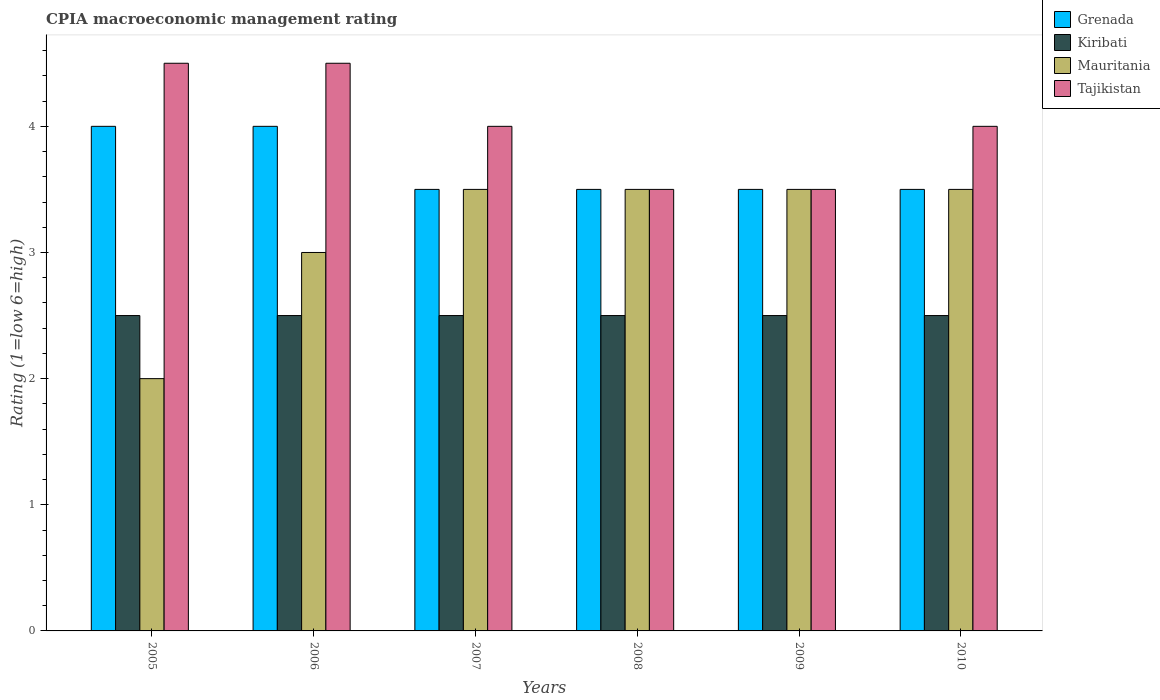Are the number of bars on each tick of the X-axis equal?
Your answer should be very brief. Yes. How many bars are there on the 4th tick from the left?
Make the answer very short. 4. How many bars are there on the 1st tick from the right?
Make the answer very short. 4. In which year was the CPIA rating in Grenada maximum?
Your response must be concise. 2005. In which year was the CPIA rating in Kiribati minimum?
Make the answer very short. 2005. What is the difference between the CPIA rating in Kiribati in 2008 and that in 2010?
Give a very brief answer. 0. What is the average CPIA rating in Grenada per year?
Keep it short and to the point. 3.67. In the year 2010, what is the difference between the CPIA rating in Mauritania and CPIA rating in Tajikistan?
Your answer should be compact. -0.5. In how many years, is the CPIA rating in Mauritania greater than 0.6000000000000001?
Provide a succinct answer. 6. What is the ratio of the CPIA rating in Grenada in 2006 to that in 2007?
Keep it short and to the point. 1.14. Is the CPIA rating in Mauritania in 2008 less than that in 2009?
Your answer should be compact. No. In how many years, is the CPIA rating in Grenada greater than the average CPIA rating in Grenada taken over all years?
Your response must be concise. 2. Is it the case that in every year, the sum of the CPIA rating in Kiribati and CPIA rating in Mauritania is greater than the sum of CPIA rating in Tajikistan and CPIA rating in Grenada?
Offer a very short reply. No. What does the 4th bar from the left in 2010 represents?
Ensure brevity in your answer.  Tajikistan. What does the 4th bar from the right in 2007 represents?
Ensure brevity in your answer.  Grenada. Is it the case that in every year, the sum of the CPIA rating in Tajikistan and CPIA rating in Grenada is greater than the CPIA rating in Kiribati?
Keep it short and to the point. Yes. How many years are there in the graph?
Your answer should be compact. 6. Does the graph contain any zero values?
Your answer should be very brief. No. Where does the legend appear in the graph?
Provide a succinct answer. Top right. How many legend labels are there?
Your answer should be very brief. 4. How are the legend labels stacked?
Your answer should be compact. Vertical. What is the title of the graph?
Give a very brief answer. CPIA macroeconomic management rating. Does "Djibouti" appear as one of the legend labels in the graph?
Keep it short and to the point. No. What is the label or title of the Y-axis?
Keep it short and to the point. Rating (1=low 6=high). What is the Rating (1=low 6=high) in Grenada in 2005?
Your answer should be very brief. 4. What is the Rating (1=low 6=high) in Mauritania in 2005?
Offer a terse response. 2. What is the Rating (1=low 6=high) of Tajikistan in 2005?
Make the answer very short. 4.5. What is the Rating (1=low 6=high) in Mauritania in 2006?
Your response must be concise. 3. What is the Rating (1=low 6=high) in Mauritania in 2007?
Give a very brief answer. 3.5. What is the Rating (1=low 6=high) in Tajikistan in 2007?
Your answer should be compact. 4. What is the Rating (1=low 6=high) in Grenada in 2008?
Provide a short and direct response. 3.5. What is the Rating (1=low 6=high) in Kiribati in 2008?
Your answer should be very brief. 2.5. What is the Rating (1=low 6=high) of Tajikistan in 2008?
Make the answer very short. 3.5. What is the Rating (1=low 6=high) in Kiribati in 2009?
Offer a terse response. 2.5. What is the Rating (1=low 6=high) of Grenada in 2010?
Make the answer very short. 3.5. What is the Rating (1=low 6=high) of Kiribati in 2010?
Your response must be concise. 2.5. What is the Rating (1=low 6=high) in Mauritania in 2010?
Ensure brevity in your answer.  3.5. What is the Rating (1=low 6=high) in Tajikistan in 2010?
Ensure brevity in your answer.  4. Across all years, what is the maximum Rating (1=low 6=high) in Grenada?
Provide a succinct answer. 4. Across all years, what is the maximum Rating (1=low 6=high) of Mauritania?
Your response must be concise. 3.5. Across all years, what is the minimum Rating (1=low 6=high) in Kiribati?
Keep it short and to the point. 2.5. Across all years, what is the minimum Rating (1=low 6=high) of Mauritania?
Offer a very short reply. 2. Across all years, what is the minimum Rating (1=low 6=high) of Tajikistan?
Give a very brief answer. 3.5. What is the total Rating (1=low 6=high) of Grenada in the graph?
Provide a succinct answer. 22. What is the total Rating (1=low 6=high) in Mauritania in the graph?
Your answer should be very brief. 19. What is the total Rating (1=low 6=high) in Tajikistan in the graph?
Provide a succinct answer. 24. What is the difference between the Rating (1=low 6=high) in Grenada in 2005 and that in 2006?
Offer a terse response. 0. What is the difference between the Rating (1=low 6=high) in Mauritania in 2005 and that in 2006?
Provide a short and direct response. -1. What is the difference between the Rating (1=low 6=high) of Grenada in 2005 and that in 2007?
Provide a short and direct response. 0.5. What is the difference between the Rating (1=low 6=high) of Kiribati in 2005 and that in 2007?
Offer a terse response. 0. What is the difference between the Rating (1=low 6=high) of Grenada in 2005 and that in 2008?
Give a very brief answer. 0.5. What is the difference between the Rating (1=low 6=high) in Kiribati in 2005 and that in 2008?
Offer a terse response. 0. What is the difference between the Rating (1=low 6=high) in Mauritania in 2005 and that in 2008?
Provide a succinct answer. -1.5. What is the difference between the Rating (1=low 6=high) of Grenada in 2005 and that in 2009?
Give a very brief answer. 0.5. What is the difference between the Rating (1=low 6=high) of Kiribati in 2005 and that in 2009?
Ensure brevity in your answer.  0. What is the difference between the Rating (1=low 6=high) in Grenada in 2005 and that in 2010?
Offer a terse response. 0.5. What is the difference between the Rating (1=low 6=high) in Tajikistan in 2005 and that in 2010?
Ensure brevity in your answer.  0.5. What is the difference between the Rating (1=low 6=high) of Mauritania in 2006 and that in 2007?
Provide a short and direct response. -0.5. What is the difference between the Rating (1=low 6=high) in Grenada in 2006 and that in 2008?
Ensure brevity in your answer.  0.5. What is the difference between the Rating (1=low 6=high) in Kiribati in 2006 and that in 2008?
Offer a very short reply. 0. What is the difference between the Rating (1=low 6=high) in Mauritania in 2006 and that in 2008?
Give a very brief answer. -0.5. What is the difference between the Rating (1=low 6=high) in Tajikistan in 2006 and that in 2008?
Ensure brevity in your answer.  1. What is the difference between the Rating (1=low 6=high) in Kiribati in 2006 and that in 2009?
Offer a very short reply. 0. What is the difference between the Rating (1=low 6=high) in Grenada in 2006 and that in 2010?
Your answer should be compact. 0.5. What is the difference between the Rating (1=low 6=high) of Kiribati in 2006 and that in 2010?
Keep it short and to the point. 0. What is the difference between the Rating (1=low 6=high) in Mauritania in 2006 and that in 2010?
Make the answer very short. -0.5. What is the difference between the Rating (1=low 6=high) of Tajikistan in 2006 and that in 2010?
Keep it short and to the point. 0.5. What is the difference between the Rating (1=low 6=high) of Grenada in 2007 and that in 2008?
Keep it short and to the point. 0. What is the difference between the Rating (1=low 6=high) of Tajikistan in 2007 and that in 2009?
Your answer should be very brief. 0.5. What is the difference between the Rating (1=low 6=high) of Grenada in 2007 and that in 2010?
Offer a terse response. 0. What is the difference between the Rating (1=low 6=high) of Tajikistan in 2007 and that in 2010?
Keep it short and to the point. 0. What is the difference between the Rating (1=low 6=high) in Kiribati in 2008 and that in 2009?
Keep it short and to the point. 0. What is the difference between the Rating (1=low 6=high) of Mauritania in 2008 and that in 2009?
Your answer should be very brief. 0. What is the difference between the Rating (1=low 6=high) of Tajikistan in 2008 and that in 2009?
Keep it short and to the point. 0. What is the difference between the Rating (1=low 6=high) of Grenada in 2008 and that in 2010?
Your answer should be compact. 0. What is the difference between the Rating (1=low 6=high) of Mauritania in 2008 and that in 2010?
Provide a short and direct response. 0. What is the difference between the Rating (1=low 6=high) in Kiribati in 2009 and that in 2010?
Your answer should be compact. 0. What is the difference between the Rating (1=low 6=high) of Grenada in 2005 and the Rating (1=low 6=high) of Kiribati in 2006?
Provide a short and direct response. 1.5. What is the difference between the Rating (1=low 6=high) of Grenada in 2005 and the Rating (1=low 6=high) of Mauritania in 2006?
Make the answer very short. 1. What is the difference between the Rating (1=low 6=high) of Mauritania in 2005 and the Rating (1=low 6=high) of Tajikistan in 2006?
Offer a very short reply. -2.5. What is the difference between the Rating (1=low 6=high) in Kiribati in 2005 and the Rating (1=low 6=high) in Tajikistan in 2007?
Ensure brevity in your answer.  -1.5. What is the difference between the Rating (1=low 6=high) in Mauritania in 2005 and the Rating (1=low 6=high) in Tajikistan in 2007?
Provide a succinct answer. -2. What is the difference between the Rating (1=low 6=high) of Grenada in 2005 and the Rating (1=low 6=high) of Tajikistan in 2008?
Give a very brief answer. 0.5. What is the difference between the Rating (1=low 6=high) in Kiribati in 2005 and the Rating (1=low 6=high) in Mauritania in 2008?
Offer a very short reply. -1. What is the difference between the Rating (1=low 6=high) of Mauritania in 2005 and the Rating (1=low 6=high) of Tajikistan in 2008?
Keep it short and to the point. -1.5. What is the difference between the Rating (1=low 6=high) of Grenada in 2005 and the Rating (1=low 6=high) of Mauritania in 2009?
Offer a terse response. 0.5. What is the difference between the Rating (1=low 6=high) of Kiribati in 2005 and the Rating (1=low 6=high) of Mauritania in 2009?
Provide a succinct answer. -1. What is the difference between the Rating (1=low 6=high) in Kiribati in 2005 and the Rating (1=low 6=high) in Tajikistan in 2009?
Your answer should be compact. -1. What is the difference between the Rating (1=low 6=high) of Kiribati in 2005 and the Rating (1=low 6=high) of Mauritania in 2010?
Offer a terse response. -1. What is the difference between the Rating (1=low 6=high) in Kiribati in 2005 and the Rating (1=low 6=high) in Tajikistan in 2010?
Provide a short and direct response. -1.5. What is the difference between the Rating (1=low 6=high) of Mauritania in 2005 and the Rating (1=low 6=high) of Tajikistan in 2010?
Provide a succinct answer. -2. What is the difference between the Rating (1=low 6=high) of Grenada in 2006 and the Rating (1=low 6=high) of Kiribati in 2007?
Provide a succinct answer. 1.5. What is the difference between the Rating (1=low 6=high) of Grenada in 2006 and the Rating (1=low 6=high) of Mauritania in 2007?
Your response must be concise. 0.5. What is the difference between the Rating (1=low 6=high) of Grenada in 2006 and the Rating (1=low 6=high) of Tajikistan in 2007?
Make the answer very short. 0. What is the difference between the Rating (1=low 6=high) in Kiribati in 2006 and the Rating (1=low 6=high) in Mauritania in 2007?
Your answer should be compact. -1. What is the difference between the Rating (1=low 6=high) of Kiribati in 2006 and the Rating (1=low 6=high) of Tajikistan in 2007?
Make the answer very short. -1.5. What is the difference between the Rating (1=low 6=high) of Mauritania in 2006 and the Rating (1=low 6=high) of Tajikistan in 2007?
Make the answer very short. -1. What is the difference between the Rating (1=low 6=high) in Grenada in 2006 and the Rating (1=low 6=high) in Kiribati in 2008?
Your response must be concise. 1.5. What is the difference between the Rating (1=low 6=high) of Grenada in 2006 and the Rating (1=low 6=high) of Tajikistan in 2008?
Offer a very short reply. 0.5. What is the difference between the Rating (1=low 6=high) of Kiribati in 2006 and the Rating (1=low 6=high) of Mauritania in 2008?
Your answer should be compact. -1. What is the difference between the Rating (1=low 6=high) of Grenada in 2006 and the Rating (1=low 6=high) of Mauritania in 2009?
Your answer should be compact. 0.5. What is the difference between the Rating (1=low 6=high) in Grenada in 2006 and the Rating (1=low 6=high) in Tajikistan in 2009?
Your answer should be very brief. 0.5. What is the difference between the Rating (1=low 6=high) of Kiribati in 2006 and the Rating (1=low 6=high) of Mauritania in 2009?
Your response must be concise. -1. What is the difference between the Rating (1=low 6=high) in Grenada in 2006 and the Rating (1=low 6=high) in Kiribati in 2010?
Ensure brevity in your answer.  1.5. What is the difference between the Rating (1=low 6=high) of Grenada in 2006 and the Rating (1=low 6=high) of Tajikistan in 2010?
Your answer should be very brief. 0. What is the difference between the Rating (1=low 6=high) in Kiribati in 2006 and the Rating (1=low 6=high) in Mauritania in 2010?
Your response must be concise. -1. What is the difference between the Rating (1=low 6=high) of Kiribati in 2006 and the Rating (1=low 6=high) of Tajikistan in 2010?
Provide a short and direct response. -1.5. What is the difference between the Rating (1=low 6=high) of Mauritania in 2006 and the Rating (1=low 6=high) of Tajikistan in 2010?
Give a very brief answer. -1. What is the difference between the Rating (1=low 6=high) in Grenada in 2007 and the Rating (1=low 6=high) in Kiribati in 2008?
Make the answer very short. 1. What is the difference between the Rating (1=low 6=high) in Grenada in 2007 and the Rating (1=low 6=high) in Tajikistan in 2008?
Provide a succinct answer. 0. What is the difference between the Rating (1=low 6=high) in Kiribati in 2007 and the Rating (1=low 6=high) in Mauritania in 2008?
Provide a short and direct response. -1. What is the difference between the Rating (1=low 6=high) in Kiribati in 2007 and the Rating (1=low 6=high) in Tajikistan in 2008?
Make the answer very short. -1. What is the difference between the Rating (1=low 6=high) of Mauritania in 2007 and the Rating (1=low 6=high) of Tajikistan in 2008?
Make the answer very short. 0. What is the difference between the Rating (1=low 6=high) of Grenada in 2007 and the Rating (1=low 6=high) of Kiribati in 2009?
Give a very brief answer. 1. What is the difference between the Rating (1=low 6=high) in Kiribati in 2007 and the Rating (1=low 6=high) in Tajikistan in 2009?
Offer a very short reply. -1. What is the difference between the Rating (1=low 6=high) in Mauritania in 2007 and the Rating (1=low 6=high) in Tajikistan in 2009?
Provide a succinct answer. 0. What is the difference between the Rating (1=low 6=high) of Kiribati in 2007 and the Rating (1=low 6=high) of Mauritania in 2010?
Give a very brief answer. -1. What is the difference between the Rating (1=low 6=high) of Kiribati in 2007 and the Rating (1=low 6=high) of Tajikistan in 2010?
Offer a very short reply. -1.5. What is the difference between the Rating (1=low 6=high) in Grenada in 2008 and the Rating (1=low 6=high) in Kiribati in 2009?
Provide a succinct answer. 1. What is the difference between the Rating (1=low 6=high) in Grenada in 2008 and the Rating (1=low 6=high) in Mauritania in 2009?
Your response must be concise. 0. What is the difference between the Rating (1=low 6=high) in Kiribati in 2008 and the Rating (1=low 6=high) in Mauritania in 2009?
Provide a short and direct response. -1. What is the difference between the Rating (1=low 6=high) of Grenada in 2008 and the Rating (1=low 6=high) of Kiribati in 2010?
Your answer should be compact. 1. What is the difference between the Rating (1=low 6=high) of Grenada in 2008 and the Rating (1=low 6=high) of Tajikistan in 2010?
Make the answer very short. -0.5. What is the difference between the Rating (1=low 6=high) in Kiribati in 2008 and the Rating (1=low 6=high) in Tajikistan in 2010?
Your answer should be very brief. -1.5. What is the difference between the Rating (1=low 6=high) of Mauritania in 2008 and the Rating (1=low 6=high) of Tajikistan in 2010?
Your response must be concise. -0.5. What is the difference between the Rating (1=low 6=high) of Grenada in 2009 and the Rating (1=low 6=high) of Kiribati in 2010?
Your answer should be compact. 1. What is the average Rating (1=low 6=high) of Grenada per year?
Your answer should be compact. 3.67. What is the average Rating (1=low 6=high) in Mauritania per year?
Provide a succinct answer. 3.17. What is the average Rating (1=low 6=high) of Tajikistan per year?
Offer a very short reply. 4. In the year 2005, what is the difference between the Rating (1=low 6=high) of Grenada and Rating (1=low 6=high) of Mauritania?
Give a very brief answer. 2. In the year 2005, what is the difference between the Rating (1=low 6=high) of Kiribati and Rating (1=low 6=high) of Mauritania?
Ensure brevity in your answer.  0.5. In the year 2005, what is the difference between the Rating (1=low 6=high) in Kiribati and Rating (1=low 6=high) in Tajikistan?
Your answer should be very brief. -2. In the year 2005, what is the difference between the Rating (1=low 6=high) in Mauritania and Rating (1=low 6=high) in Tajikistan?
Ensure brevity in your answer.  -2.5. In the year 2007, what is the difference between the Rating (1=low 6=high) in Grenada and Rating (1=low 6=high) in Mauritania?
Offer a terse response. 0. In the year 2007, what is the difference between the Rating (1=low 6=high) in Grenada and Rating (1=low 6=high) in Tajikistan?
Keep it short and to the point. -0.5. In the year 2007, what is the difference between the Rating (1=low 6=high) of Kiribati and Rating (1=low 6=high) of Mauritania?
Make the answer very short. -1. In the year 2007, what is the difference between the Rating (1=low 6=high) in Kiribati and Rating (1=low 6=high) in Tajikistan?
Offer a very short reply. -1.5. In the year 2007, what is the difference between the Rating (1=low 6=high) in Mauritania and Rating (1=low 6=high) in Tajikistan?
Provide a short and direct response. -0.5. In the year 2008, what is the difference between the Rating (1=low 6=high) of Grenada and Rating (1=low 6=high) of Kiribati?
Make the answer very short. 1. In the year 2008, what is the difference between the Rating (1=low 6=high) of Grenada and Rating (1=low 6=high) of Mauritania?
Offer a terse response. 0. In the year 2008, what is the difference between the Rating (1=low 6=high) of Kiribati and Rating (1=low 6=high) of Tajikistan?
Keep it short and to the point. -1. In the year 2009, what is the difference between the Rating (1=low 6=high) in Grenada and Rating (1=low 6=high) in Tajikistan?
Provide a short and direct response. 0. In the year 2009, what is the difference between the Rating (1=low 6=high) in Kiribati and Rating (1=low 6=high) in Mauritania?
Your response must be concise. -1. In the year 2009, what is the difference between the Rating (1=low 6=high) in Kiribati and Rating (1=low 6=high) in Tajikistan?
Give a very brief answer. -1. In the year 2010, what is the difference between the Rating (1=low 6=high) in Grenada and Rating (1=low 6=high) in Kiribati?
Give a very brief answer. 1. In the year 2010, what is the difference between the Rating (1=low 6=high) in Grenada and Rating (1=low 6=high) in Tajikistan?
Keep it short and to the point. -0.5. In the year 2010, what is the difference between the Rating (1=low 6=high) of Kiribati and Rating (1=low 6=high) of Tajikistan?
Your answer should be compact. -1.5. What is the ratio of the Rating (1=low 6=high) in Tajikistan in 2005 to that in 2006?
Offer a very short reply. 1. What is the ratio of the Rating (1=low 6=high) in Tajikistan in 2005 to that in 2007?
Provide a succinct answer. 1.12. What is the ratio of the Rating (1=low 6=high) in Mauritania in 2005 to that in 2008?
Make the answer very short. 0.57. What is the ratio of the Rating (1=low 6=high) of Grenada in 2005 to that in 2009?
Keep it short and to the point. 1.14. What is the ratio of the Rating (1=low 6=high) in Kiribati in 2005 to that in 2009?
Provide a short and direct response. 1. What is the ratio of the Rating (1=low 6=high) of Mauritania in 2005 to that in 2009?
Your response must be concise. 0.57. What is the ratio of the Rating (1=low 6=high) of Tajikistan in 2005 to that in 2009?
Offer a very short reply. 1.29. What is the ratio of the Rating (1=low 6=high) of Mauritania in 2005 to that in 2010?
Provide a short and direct response. 0.57. What is the ratio of the Rating (1=low 6=high) in Kiribati in 2006 to that in 2007?
Your answer should be very brief. 1. What is the ratio of the Rating (1=low 6=high) of Tajikistan in 2006 to that in 2007?
Your response must be concise. 1.12. What is the ratio of the Rating (1=low 6=high) in Grenada in 2006 to that in 2008?
Your answer should be compact. 1.14. What is the ratio of the Rating (1=low 6=high) of Kiribati in 2006 to that in 2008?
Offer a terse response. 1. What is the ratio of the Rating (1=low 6=high) in Mauritania in 2006 to that in 2009?
Give a very brief answer. 0.86. What is the ratio of the Rating (1=low 6=high) of Kiribati in 2006 to that in 2010?
Provide a short and direct response. 1. What is the ratio of the Rating (1=low 6=high) of Mauritania in 2006 to that in 2010?
Give a very brief answer. 0.86. What is the ratio of the Rating (1=low 6=high) in Tajikistan in 2007 to that in 2008?
Keep it short and to the point. 1.14. What is the ratio of the Rating (1=low 6=high) in Grenada in 2007 to that in 2009?
Give a very brief answer. 1. What is the ratio of the Rating (1=low 6=high) of Kiribati in 2007 to that in 2009?
Offer a terse response. 1. What is the ratio of the Rating (1=low 6=high) in Tajikistan in 2007 to that in 2009?
Give a very brief answer. 1.14. What is the ratio of the Rating (1=low 6=high) of Grenada in 2007 to that in 2010?
Give a very brief answer. 1. What is the ratio of the Rating (1=low 6=high) in Kiribati in 2007 to that in 2010?
Keep it short and to the point. 1. What is the ratio of the Rating (1=low 6=high) of Mauritania in 2008 to that in 2009?
Offer a terse response. 1. What is the ratio of the Rating (1=low 6=high) in Tajikistan in 2008 to that in 2009?
Provide a succinct answer. 1. What is the ratio of the Rating (1=low 6=high) in Grenada in 2008 to that in 2010?
Make the answer very short. 1. What is the ratio of the Rating (1=low 6=high) in Kiribati in 2008 to that in 2010?
Give a very brief answer. 1. What is the ratio of the Rating (1=low 6=high) in Mauritania in 2008 to that in 2010?
Keep it short and to the point. 1. What is the ratio of the Rating (1=low 6=high) of Tajikistan in 2008 to that in 2010?
Ensure brevity in your answer.  0.88. What is the ratio of the Rating (1=low 6=high) in Kiribati in 2009 to that in 2010?
Offer a terse response. 1. What is the difference between the highest and the second highest Rating (1=low 6=high) of Kiribati?
Keep it short and to the point. 0. What is the difference between the highest and the lowest Rating (1=low 6=high) of Mauritania?
Give a very brief answer. 1.5. 